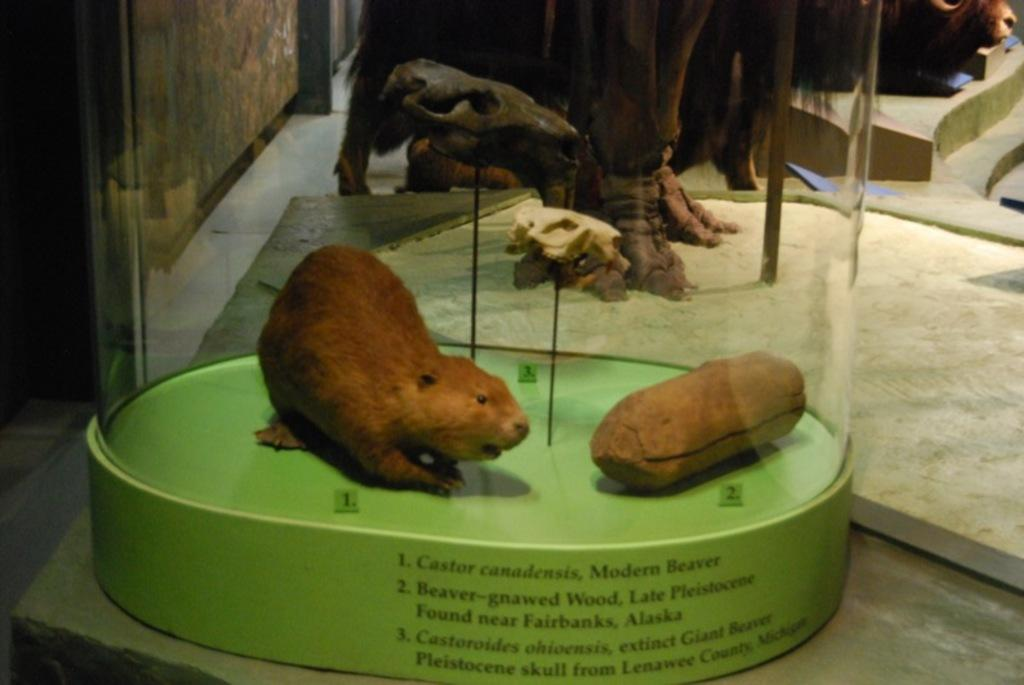What is the main subject on the green color box in the image? There is an animal visible on a green color box in the image. What can be seen at the top of the image? There is a sculpture at the top of the image. What is depicted in the sculpture? There are animals visible in the sculpture. What information is provided on the green color box? There is text on the green color box. Where is the locket with the lace design located in the image? There is no locket or lace design present in the image. 